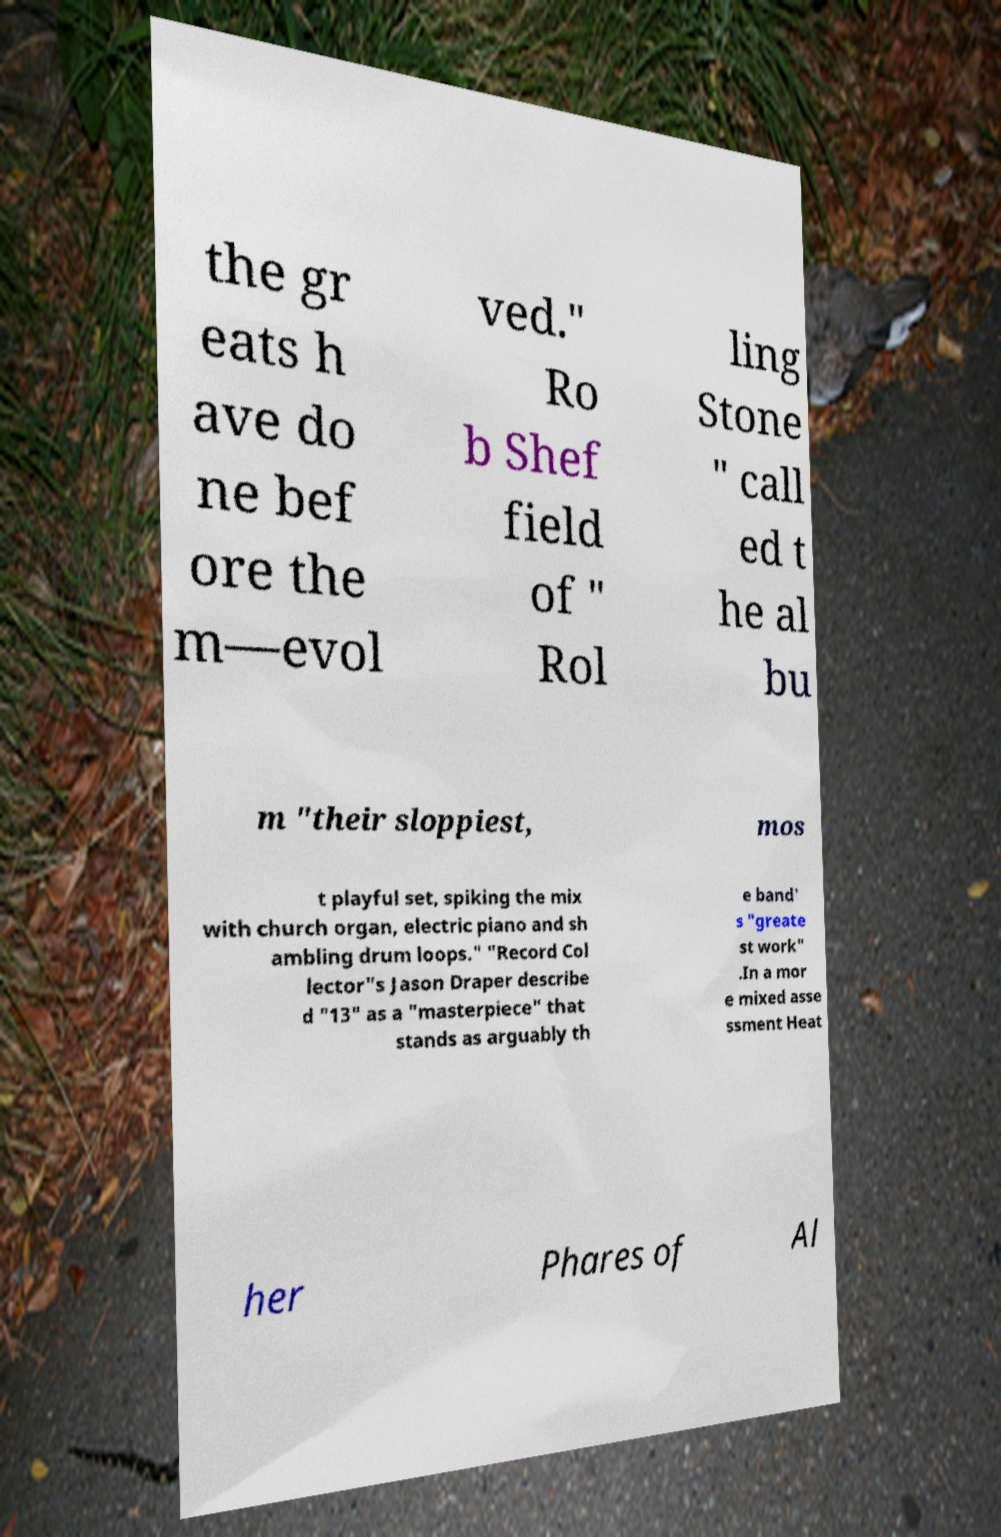Please identify and transcribe the text found in this image. the gr eats h ave do ne bef ore the m—evol ved." Ro b Shef field of " Rol ling Stone " call ed t he al bu m "their sloppiest, mos t playful set, spiking the mix with church organ, electric piano and sh ambling drum loops." "Record Col lector"s Jason Draper describe d "13" as a "masterpiece" that stands as arguably th e band' s "greate st work" .In a mor e mixed asse ssment Heat her Phares of Al 